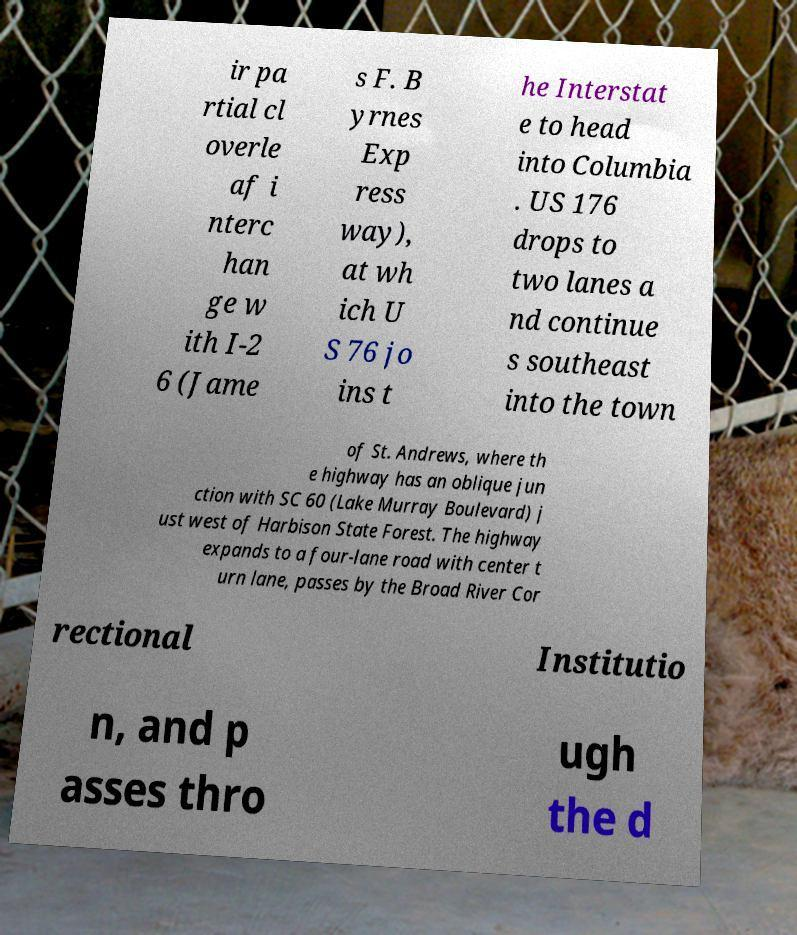What messages or text are displayed in this image? I need them in a readable, typed format. ir pa rtial cl overle af i nterc han ge w ith I-2 6 (Jame s F. B yrnes Exp ress way), at wh ich U S 76 jo ins t he Interstat e to head into Columbia . US 176 drops to two lanes a nd continue s southeast into the town of St. Andrews, where th e highway has an oblique jun ction with SC 60 (Lake Murray Boulevard) j ust west of Harbison State Forest. The highway expands to a four-lane road with center t urn lane, passes by the Broad River Cor rectional Institutio n, and p asses thro ugh the d 